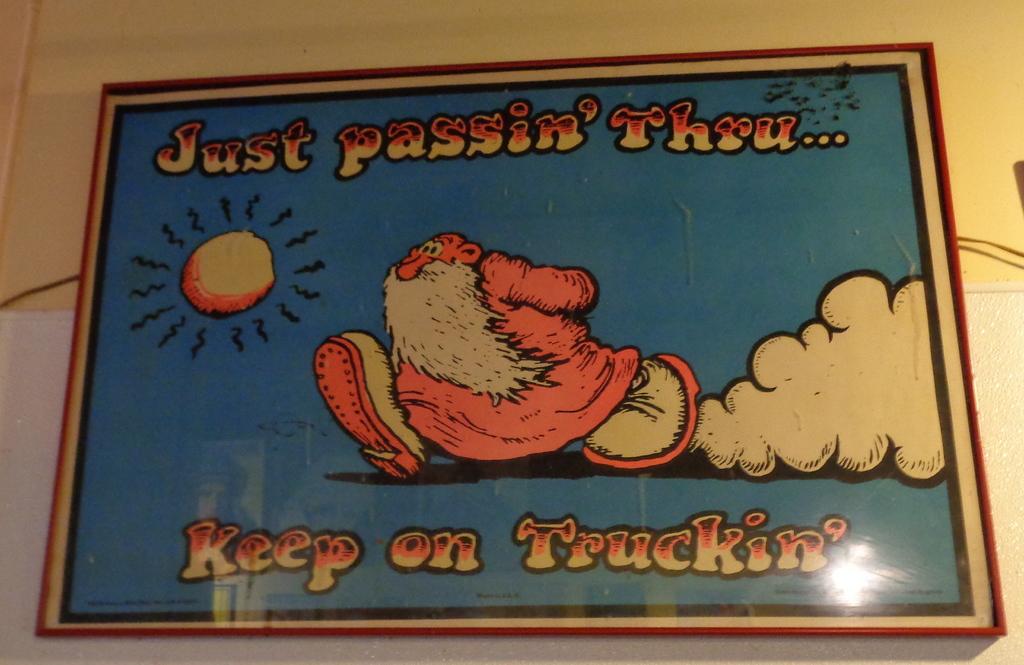What should you keep on doing?
Provide a short and direct response. Truckin'. 